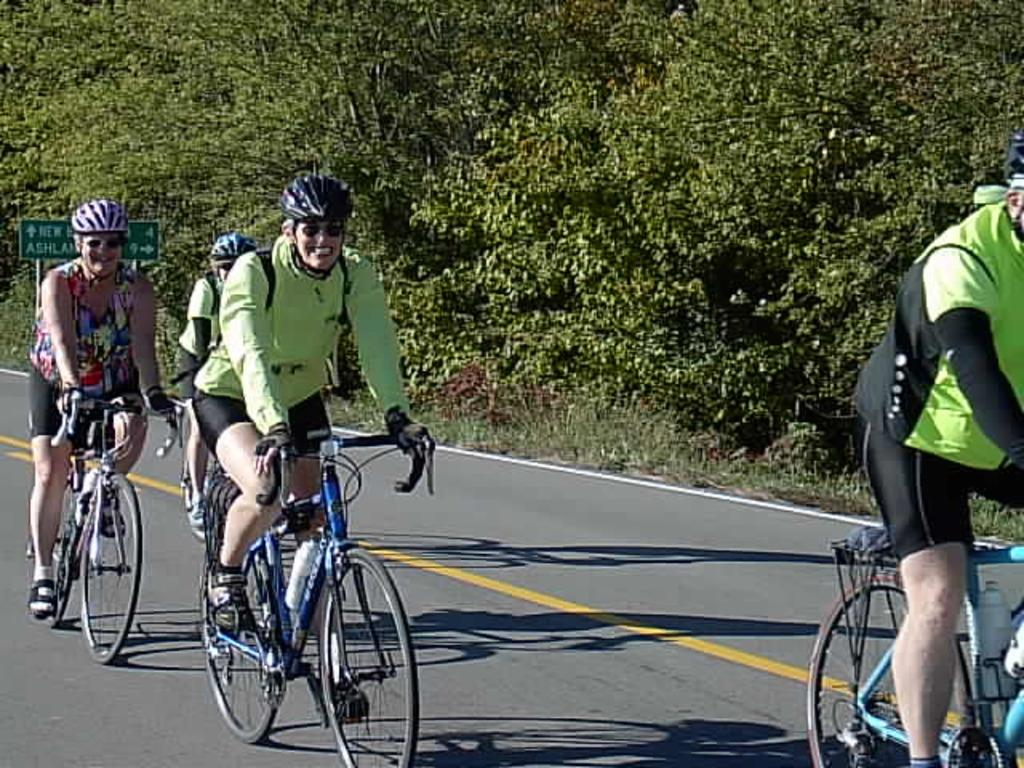What are the people in the image doing? People are riding bicycles on the road in the image. What safety precaution are the people taking while riding bicycles? The people are wearing helmets. What can be seen in the background of the image? There is a signboard, grass, and trees in the background of the image. What type of liquid is being poured from the net in the image? There is no net or liquid present in the image. What type of beef is being served on the bicycle in the image? There is no beef or bicycle serving food present in the image. 